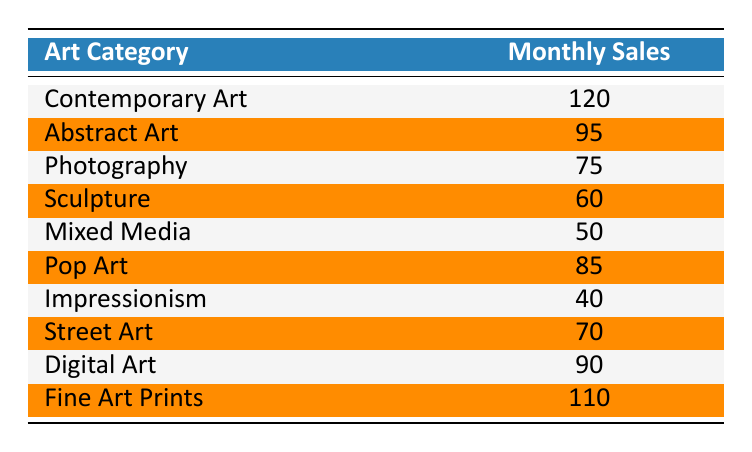What is the highest monthly sales figure among the art categories? The table shows various art categories along with their monthly sales. By examining the values, "Contemporary Art" has the highest sales value of 120.
Answer: 120 Which art category has the lowest monthly sales? Looking through the monthly sales for each category, "Impressionism" is listed with the lowest sales figure of 40.
Answer: 40 What is the total monthly sales of the top three performing art categories? The top three performing art categories are "Contemporary Art" (120), "Fine Art Prints" (110), and "Digital Art" (90). Summing these gives 120 + 110 + 90 = 320.
Answer: 320 Is the monthly sales of "Pop Art" greater than that of "Sculpture"? Comparing the monthly sales of "Pop Art" (85) and "Sculpture" (60), Pop Art has higher sales. Thus, the statement is true.
Answer: Yes What is the average monthly sales across all the listed art categories? To find the average, we sum all monthly sales: 120 + 95 + 75 + 60 + 50 + 85 + 40 + 70 + 90 + 110 = 1005. Then, we divide by the number of categories, which is 10. So, 1005 / 10 = 100.5.
Answer: 100.5 How many art categories have monthly sales figures below 80? Examining the table shows "Photography" (75), "Sculpture" (60), "Mixed Media" (50), and "Impressionism" (40) all fall below 80. This totals 4 categories.
Answer: 4 What is the difference in monthly sales between "Abstract Art" and "Digital Art"? "Abstract Art" has 95 monthly sales, while "Digital Art" has 90. The difference is calculated as 95 - 90 = 5.
Answer: 5 Is "Street Art" among the categories that sells more than 70 monthly? Checking "Street Art", we see it has 70 monthly sales, which is not more than 70. Thus, the statement is false.
Answer: No How many art categories are sold between 70 and 100 monthly? The categories falling within this range are "Abstract Art" (95), "Pop Art" (85), "Digital Art" (90), "Photography" (75), and "Street Art" (70) totaling 5 categories.
Answer: 5 